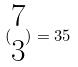<formula> <loc_0><loc_0><loc_500><loc_500>( \begin{matrix} 7 \\ 3 \end{matrix} ) = 3 5</formula> 